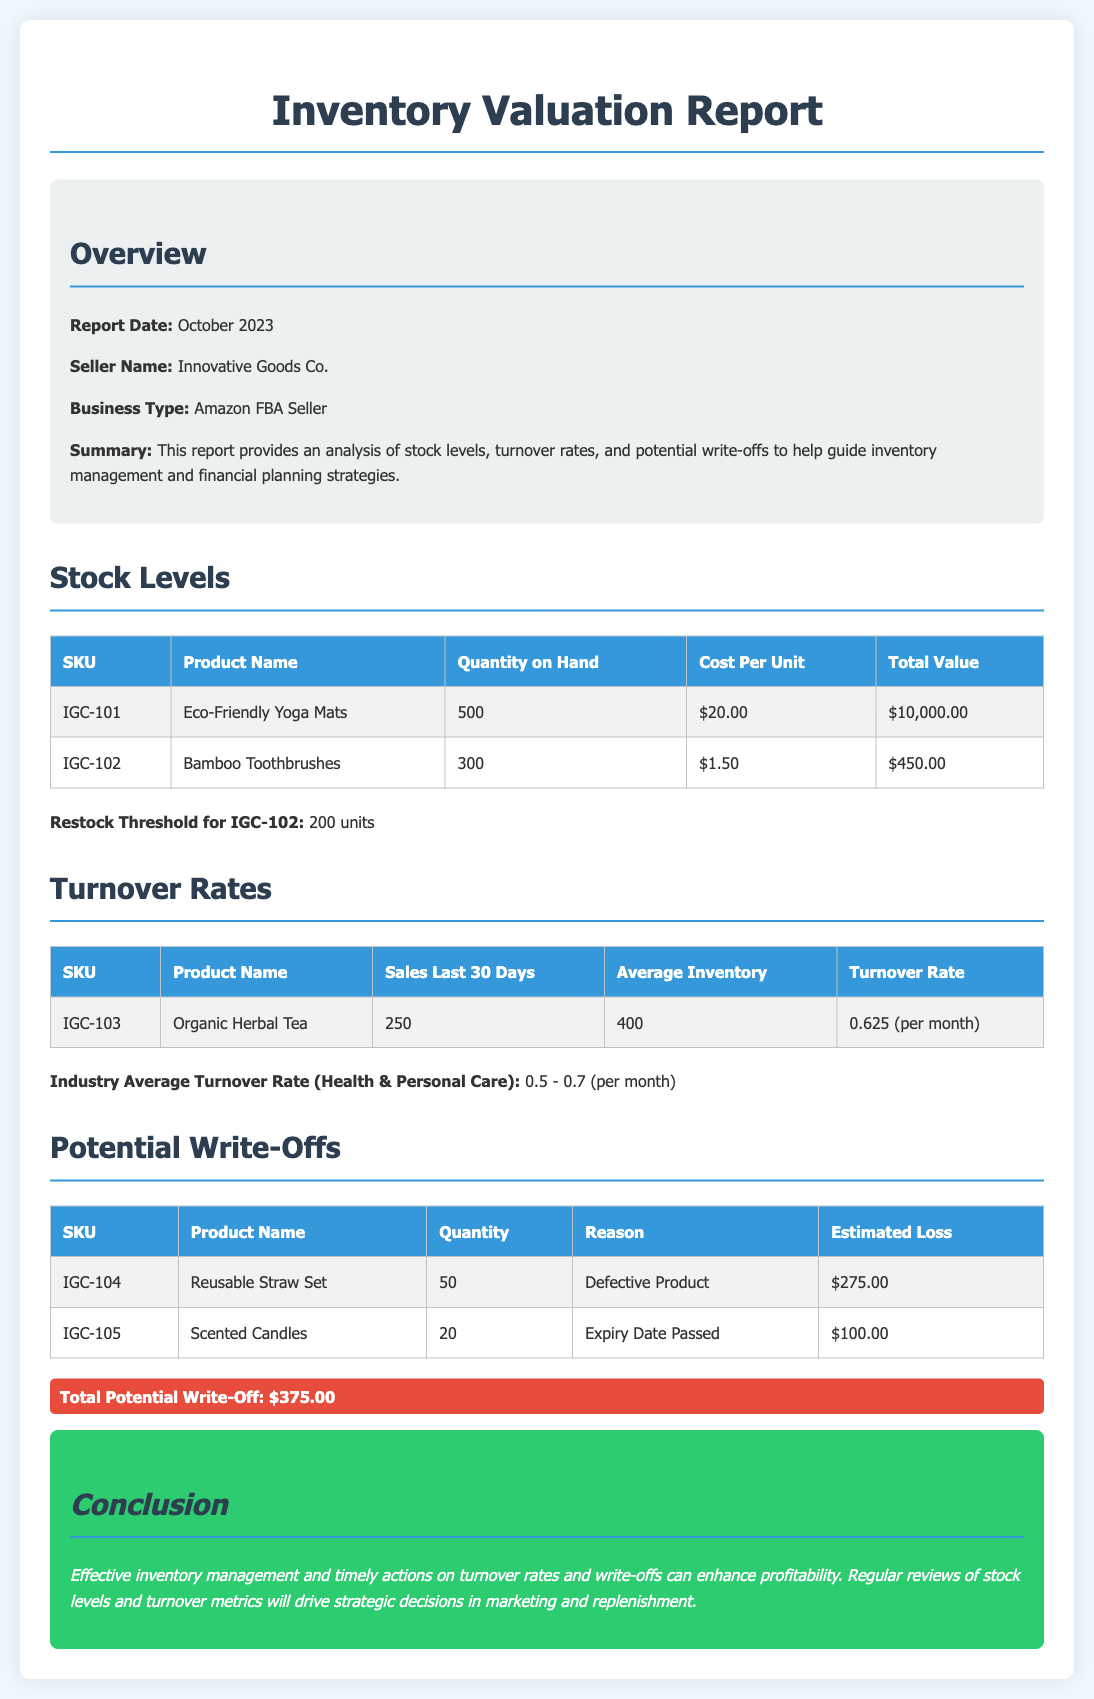What is the report date? The report date is specifically stated in the overview section of the document as October 2023.
Answer: October 2023 What is the total value of the Eco-Friendly Yoga Mats? The total value can be calculated as Quantity on Hand multiplied by Cost Per Unit for the Eco-Friendly Yoga Mats, which is 500 units * $20.00.
Answer: $10,000.00 What is the restock threshold for Bamboo Toothbrushes? The restock threshold is mentioned directly in the document under Stock Levels for SKU IGC-102 as 200 units.
Answer: 200 units What is the turnover rate for Organic Herbal Tea? The turnover rate is found in the Turnover Rates section, specifically for SKU IGC-103, stated as 0.625 per month.
Answer: 0.625 (per month) How many units of the Reusable Straw Set are potential write-offs? The quantity of potential write-offs for the Reusable Straw Set is listed under Potential Write-Offs as 50 units.
Answer: 50 What is the estimated loss for scented candles? The estimated loss for the Scented Candles is directly listed in the Potential Write-Offs table as $100.00.
Answer: $100.00 What is the total potential write-off amount? The total potential write-off is summarized in the document with a highlight that states $375.00.
Answer: $375.00 What is the business type of Innovative Goods Co.? The business type is clearly stated in the overview section as Amazon FBA Seller.
Answer: Amazon FBA Seller 